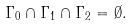Convert formula to latex. <formula><loc_0><loc_0><loc_500><loc_500>\Gamma _ { 0 } \cap \Gamma _ { 1 } \cap \Gamma _ { 2 } = \emptyset .</formula> 